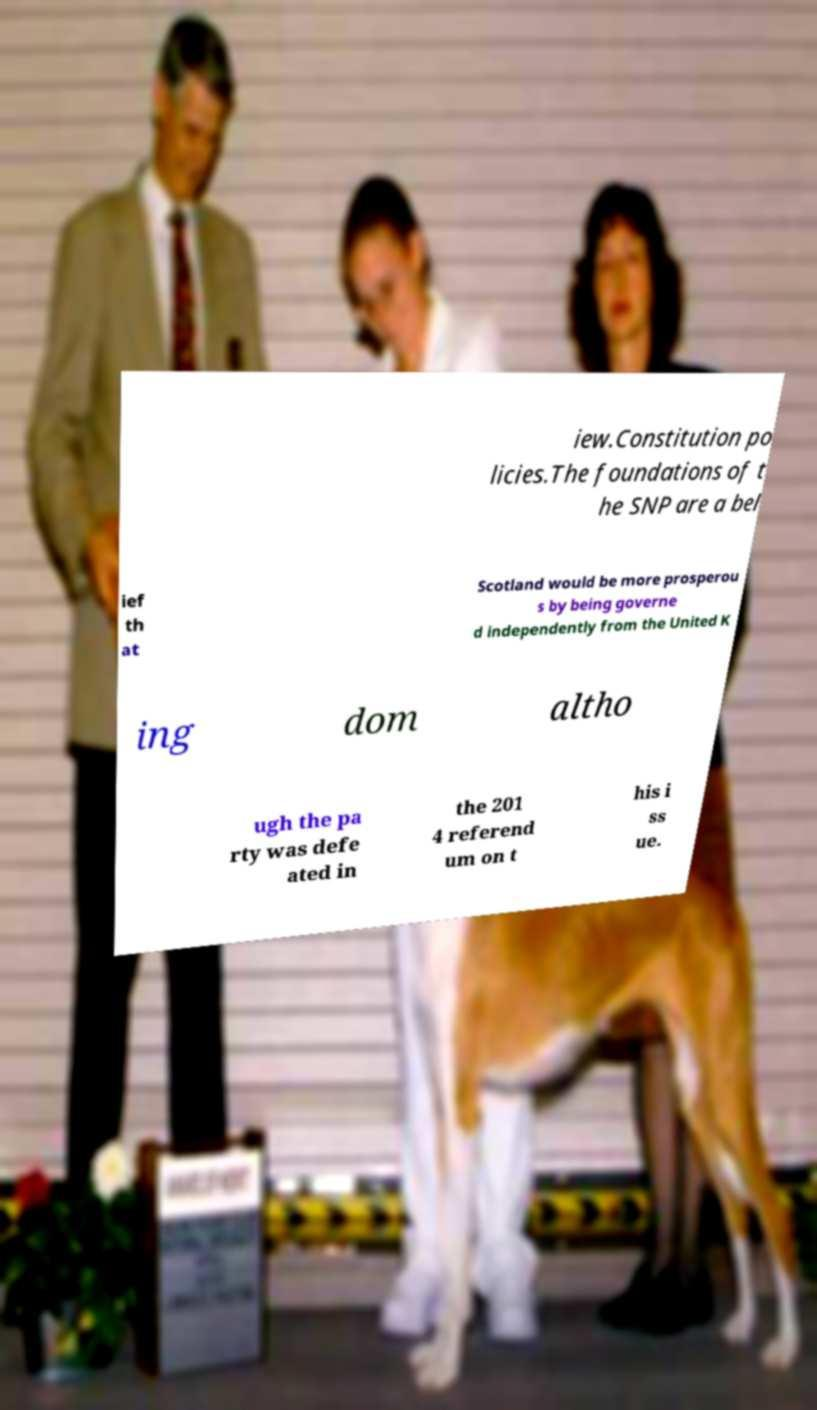Can you read and provide the text displayed in the image?This photo seems to have some interesting text. Can you extract and type it out for me? iew.Constitution po licies.The foundations of t he SNP are a bel ief th at Scotland would be more prosperou s by being governe d independently from the United K ing dom altho ugh the pa rty was defe ated in the 201 4 referend um on t his i ss ue. 